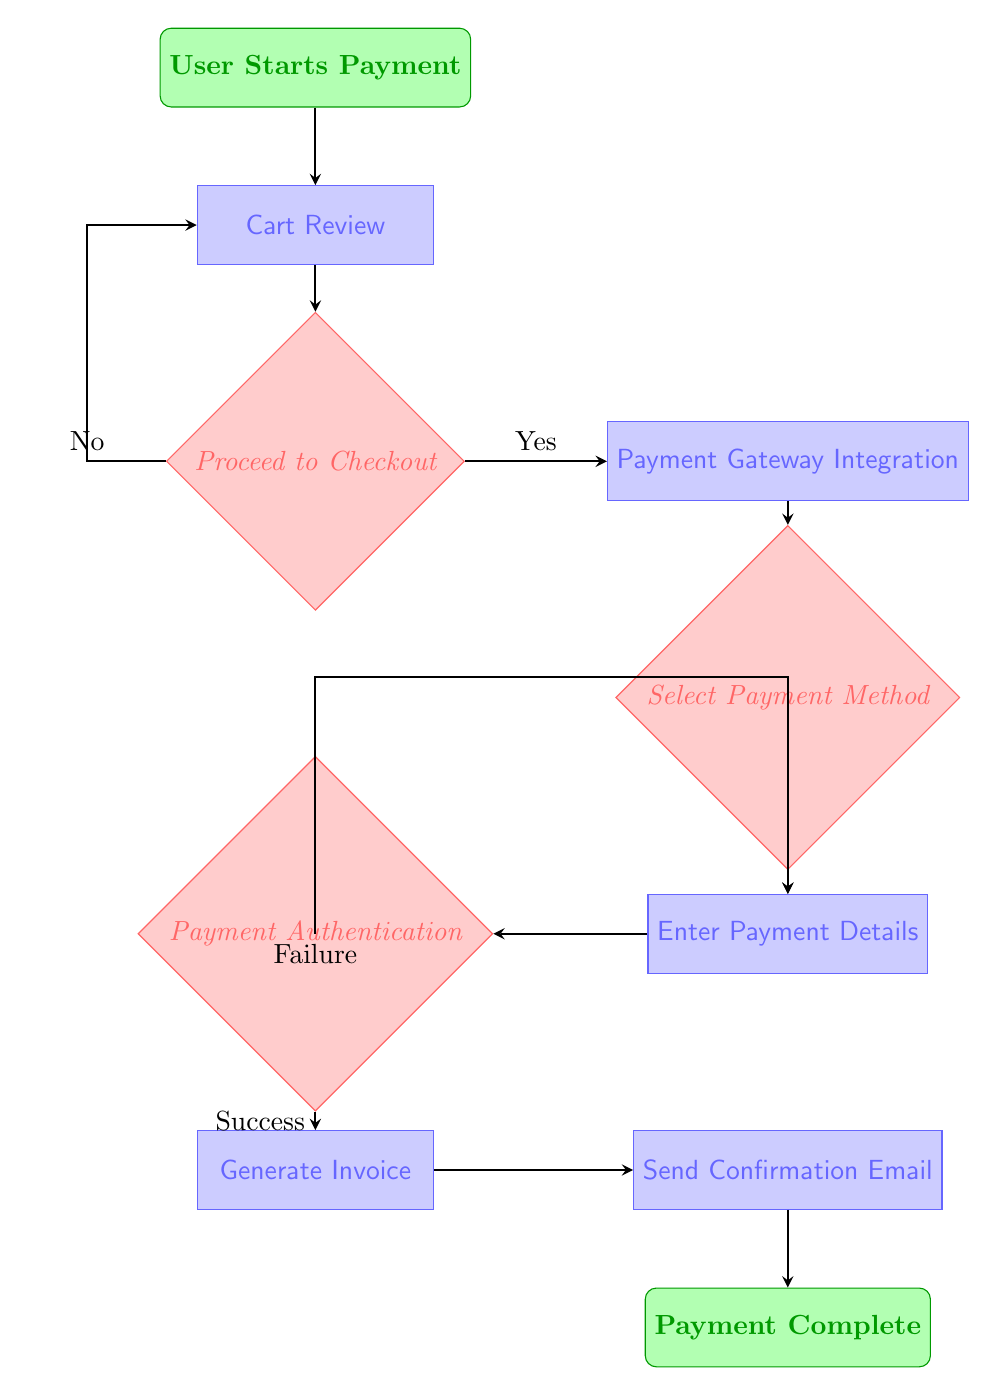What is the first step in the flow chart? The first step in the flow chart is indicated by the "User Starts Payment" node. This node is categorized as the start of the process.
Answer: User Starts Payment How many decision nodes are there in the diagram? In the diagram, there are three decision nodes: "Proceed to Checkout", "Select Payment Method", and "Payment Authentication".
Answer: 3 What happens when the user chooses 'No' at the 'Proceed to Checkout' decision? If the user selects 'No', the flow leads back to the "Cart Review" process. This is illustrated by an arrow connecting "Proceed to Checkout" to "Cart Review".
Answer: Return to Cart Review What is the next step after 'Enter Payment Details'? The next step after 'Enter Payment Details' is 'Payment Authentication'. This is indicated by the direct connection from the 'Enter Payment Details' process to the 'Payment Authentication' decision node.
Answer: Payment Authentication What are the payment methods available in the 'Select Payment Method' decision? In the 'Select Payment Method' decision, the options listed are "Credit Card", "PayPal", and "Other". This can be seen in the decision node that provides these specific choices.
Answer: Credit Card, PayPal, Other What occurs if the 'Payment Authentication' result is 'Failure'? If the result is 'Failure' at the 'Payment Authentication' decision, the flow chart shows that it loops back to 'Enter Payment Details'. This is depicted by an arrow leading from 'Payment Authentication' back to 'Enter Payment Details'.
Answer: Return to Enter Payment Details How many final steps are there after a successful payment? After a successful payment, there are three final steps: 'Generate Invoice', 'Send Confirmation Email', and 'Payment Complete'. These steps sequentially follow the 'Payment Authentication' node when the authentication is successful.
Answer: 3 